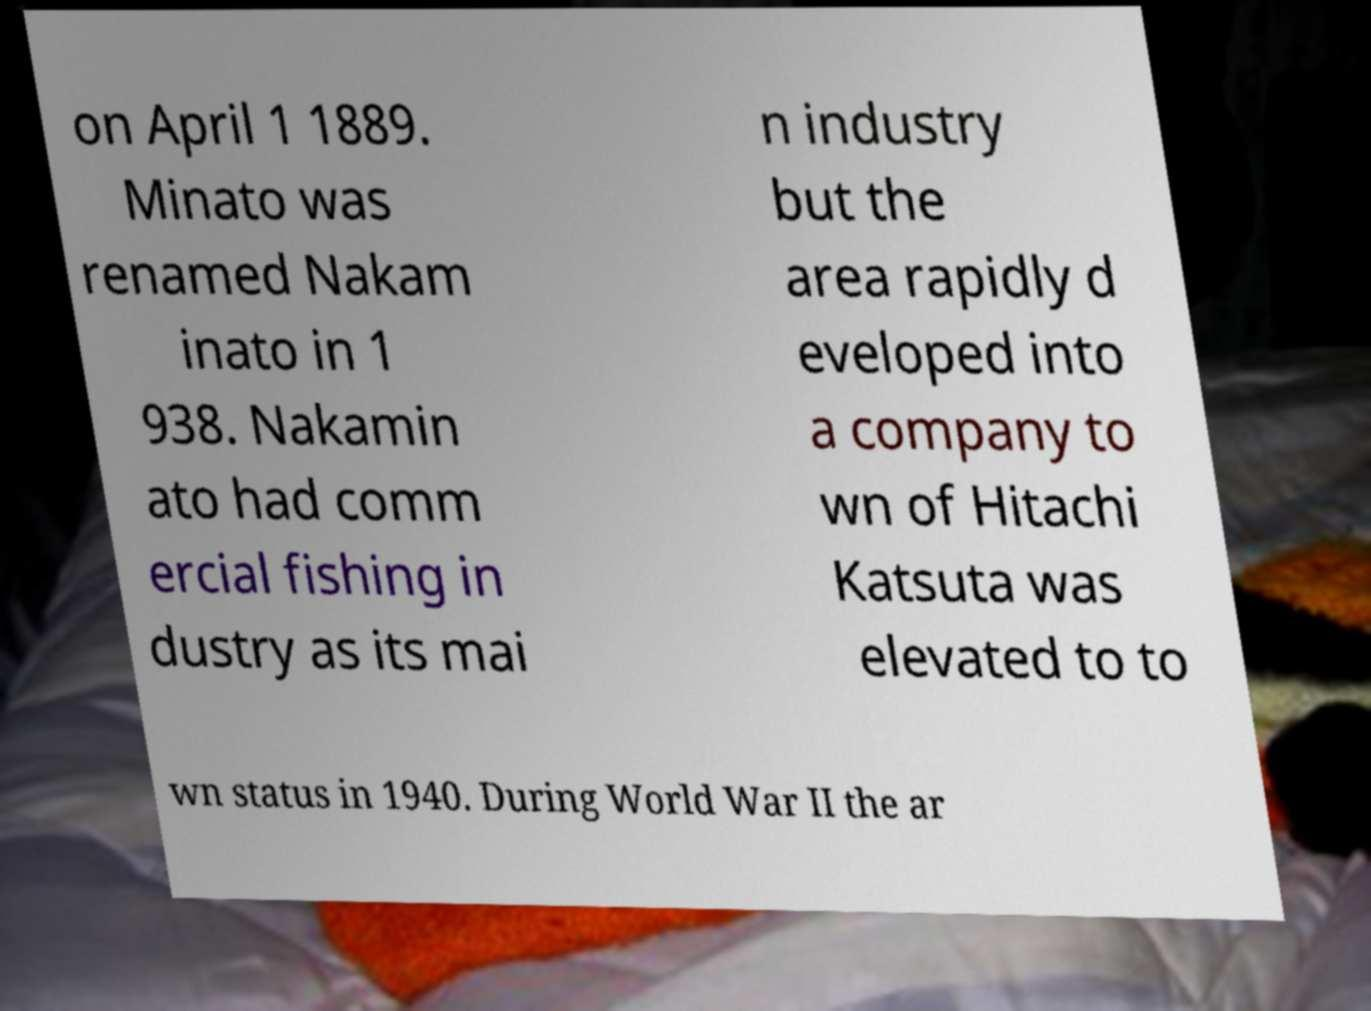There's text embedded in this image that I need extracted. Can you transcribe it verbatim? on April 1 1889. Minato was renamed Nakam inato in 1 938. Nakamin ato had comm ercial fishing in dustry as its mai n industry but the area rapidly d eveloped into a company to wn of Hitachi Katsuta was elevated to to wn status in 1940. During World War II the ar 